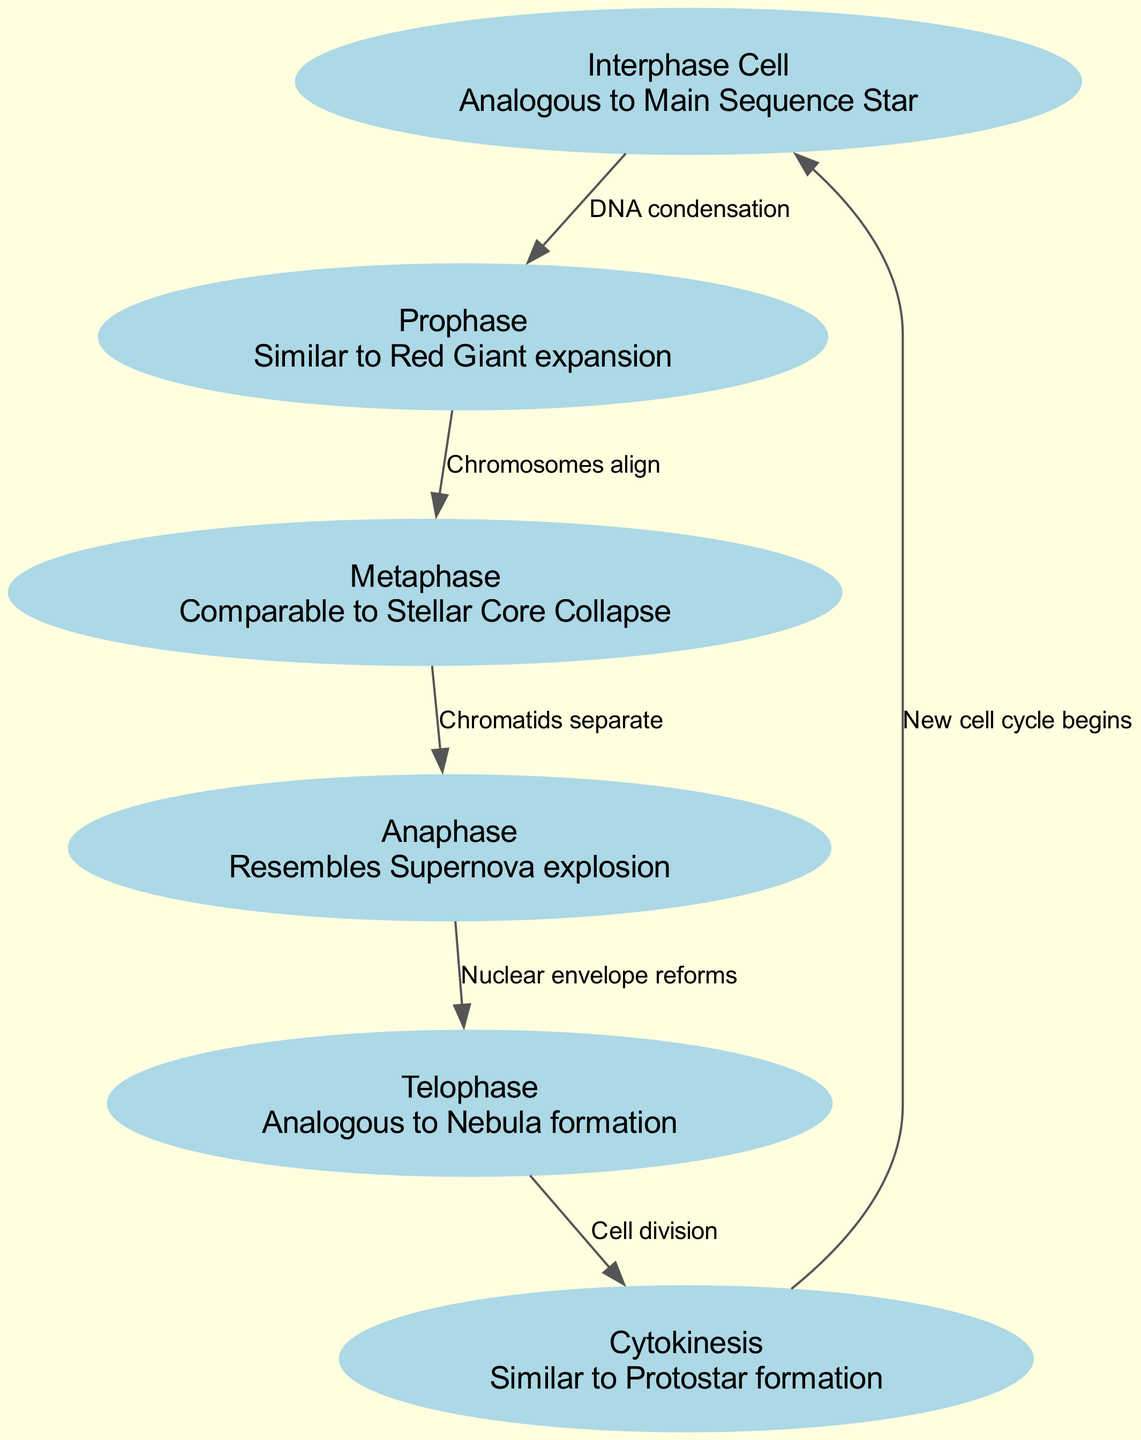What is the first stage of cellular mitosis? The first node in the diagram indicates "Interphase Cell", which is identified as the starting point of the mitosis process.
Answer: Interphase Cell How many stages are identified in the diagram? By counting the nodes provided, there are six distinct stages of cellular mitosis showcased in the diagram.
Answer: Six What is the process that follows Prophase? The diagram indicates that "Chromosomes align" is the relationship leading from "Prophase" to "Metaphase", meaning Metaphase comes directly after Prophase.
Answer: Metaphase What does Telophase represent in the lifecycle of stars? According to the description in the node, "Telophase" is analogous to "Nebula formation", providing a connection between the processes of cellular mitosis and stellar evolution.
Answer: Nebula formation How does Cytokinesis relate to the start of a new cell cycle? The edge connecting "Cytokinesis" to "Interphase Cell" describes that after cell division, a new cell cycle begins, indicating a cyclical relationship in cellular processes.
Answer: New cell cycle begins What transformation happens during Anaphase? The transition from "Metaphase" to "Anaphase" is associated with the process described as "Chromatids separate", which outlines the critical action in this stage of mitosis.
Answer: Chromatids separate What stage is compared to a "Supernova explosion"? Within the diagram, "Anaphase" is compared to a "Supernova explosion", indicating a notable event that occurs during this mitotic stage.
Answer: Anaphase Which stage corresponds to the concept of "Protostar formation"? The node labeled "Cytokinesis" specifically mentions that it is similar to "Protostar formation", linking the end of mitosis to this early phase of star development.
Answer: Protostar formation What edge label connects Metaphase and Anaphase? The label on the edge between "Metaphase" and "Anaphase" is "Chromatids separate", indicating the action that transitions between these two stages.
Answer: Chromatids separate 